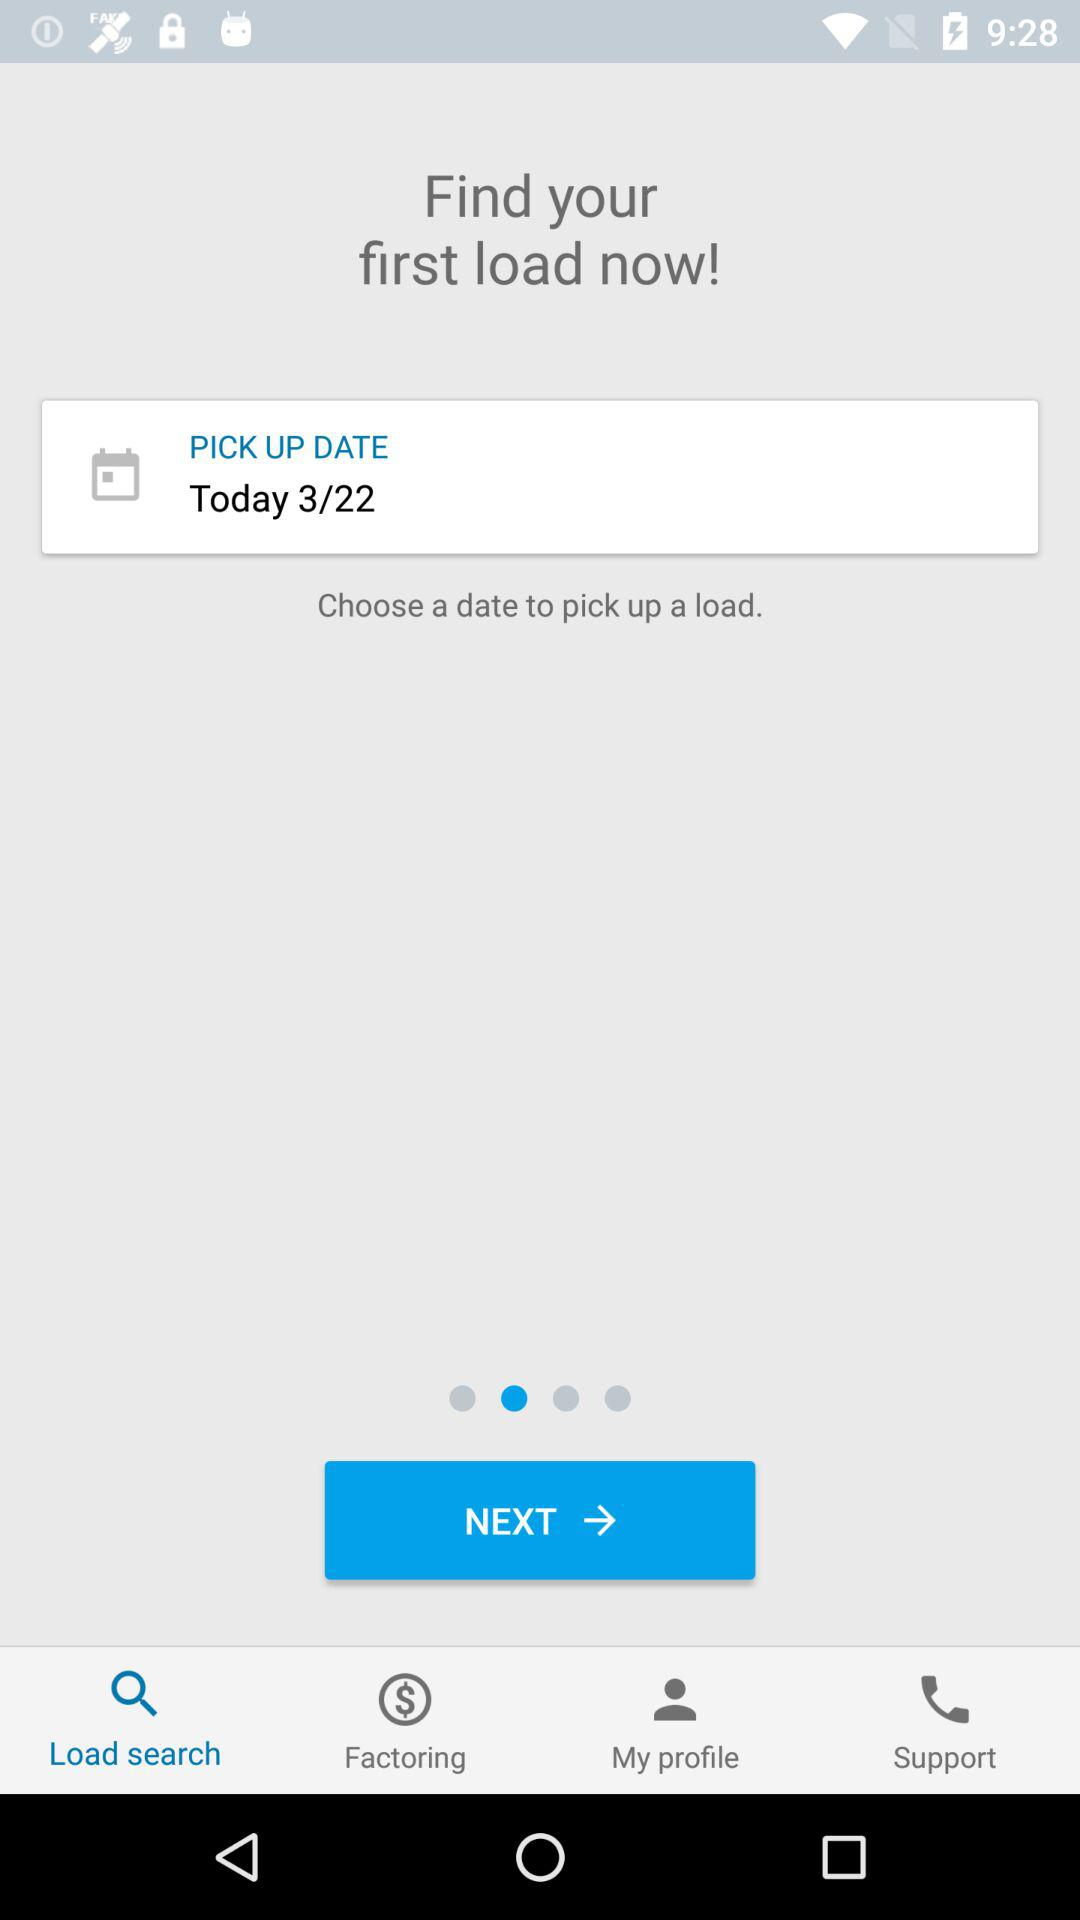What other options are available on this app interface? Alongside the option to select a pickup date, the interface offers several other functionalities. These include 'Load search' for finding available loads, 'Factoring' for financing solutions, and 'My profile' to manage personal account settings. There is also a support option available for user assistance. 